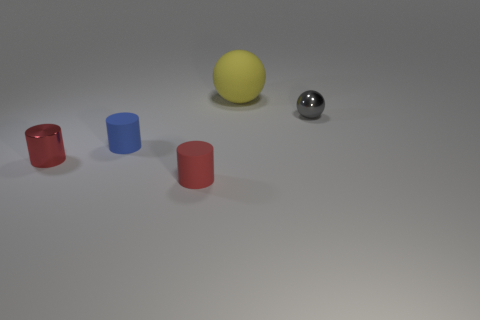Add 5 large yellow matte objects. How many objects exist? 10 Subtract all spheres. How many objects are left? 3 Subtract all small red metal cylinders. Subtract all small metal cylinders. How many objects are left? 3 Add 4 small rubber things. How many small rubber things are left? 6 Add 1 small green metal cylinders. How many small green metal cylinders exist? 1 Subtract 0 red balls. How many objects are left? 5 